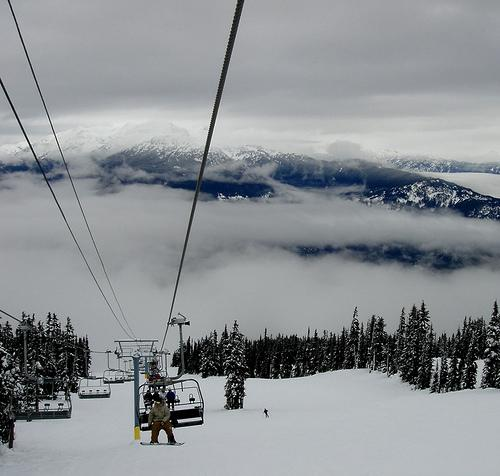Where does the carrier take the man to? Please explain your reasoning. uphill. It makes it easier to go up a mountain quickly 